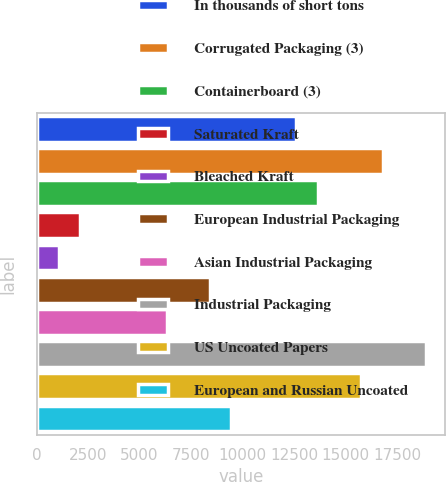Convert chart to OTSL. <chart><loc_0><loc_0><loc_500><loc_500><bar_chart><fcel>In thousands of short tons<fcel>Corrugated Packaging (3)<fcel>Containerboard (3)<fcel>Saturated Kraft<fcel>Bleached Kraft<fcel>European Industrial Packaging<fcel>Asian Industrial Packaging<fcel>Industrial Packaging<fcel>US Uncoated Papers<fcel>European and Russian Uncoated<nl><fcel>12609<fcel>16803<fcel>13657.5<fcel>2124<fcel>1075.5<fcel>8415<fcel>6318<fcel>18900<fcel>15754.5<fcel>9463.5<nl></chart> 